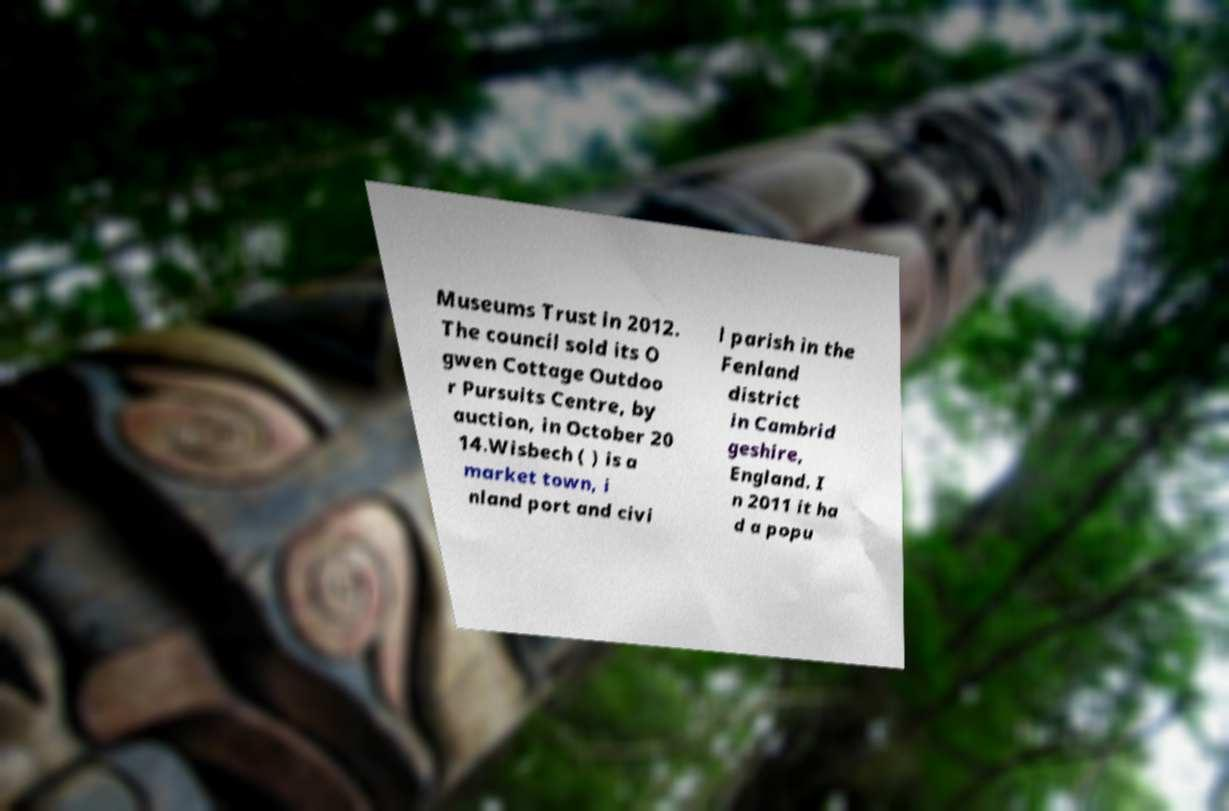There's text embedded in this image that I need extracted. Can you transcribe it verbatim? Museums Trust in 2012. The council sold its O gwen Cottage Outdoo r Pursuits Centre, by auction, in October 20 14.Wisbech ( ) is a market town, i nland port and civi l parish in the Fenland district in Cambrid geshire, England. I n 2011 it ha d a popu 